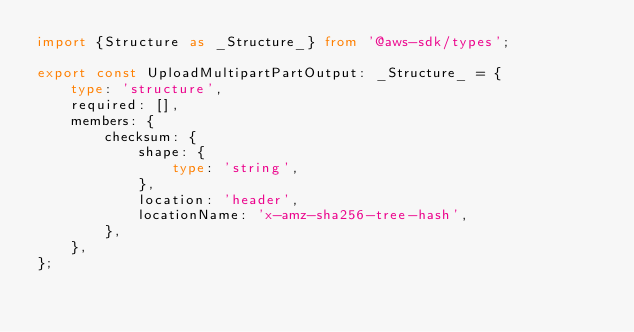<code> <loc_0><loc_0><loc_500><loc_500><_TypeScript_>import {Structure as _Structure_} from '@aws-sdk/types';

export const UploadMultipartPartOutput: _Structure_ = {
    type: 'structure',
    required: [],
    members: {
        checksum: {
            shape: {
                type: 'string',
            },
            location: 'header',
            locationName: 'x-amz-sha256-tree-hash',
        },
    },
};</code> 